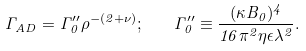Convert formula to latex. <formula><loc_0><loc_0><loc_500><loc_500>\Gamma _ { A D } = \Gamma _ { 0 } ^ { \prime \prime } \rho ^ { - ( 2 + \nu ) } ; \quad \Gamma _ { 0 } ^ { \prime \prime } \equiv \frac { ( \kappa B _ { 0 } ) ^ { 4 } } { 1 6 \pi ^ { 2 } \eta \epsilon \lambda ^ { 2 } } .</formula> 